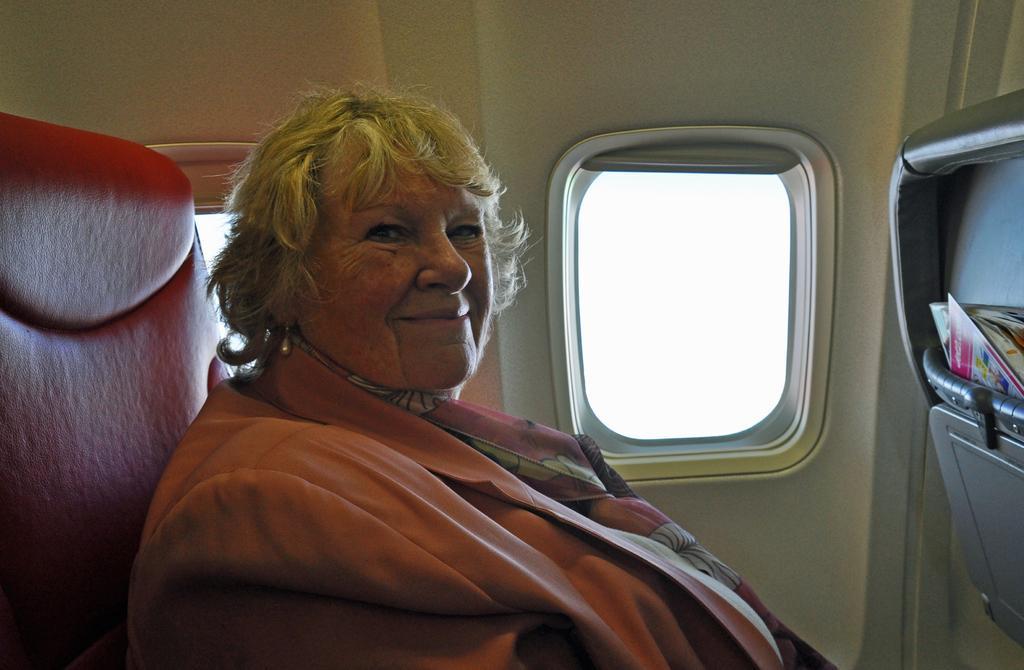Please provide a concise description of this image. There is a lady wearing scarf is sitting and smiling. This is inside a flight. Also we can see a window. On the right side there are books in a box. 